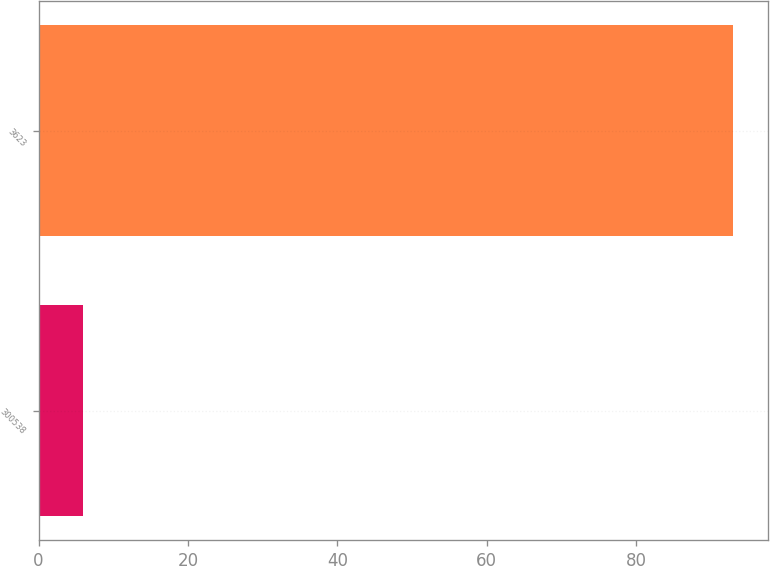<chart> <loc_0><loc_0><loc_500><loc_500><bar_chart><fcel>300538<fcel>3623<nl><fcel>6<fcel>93<nl></chart> 